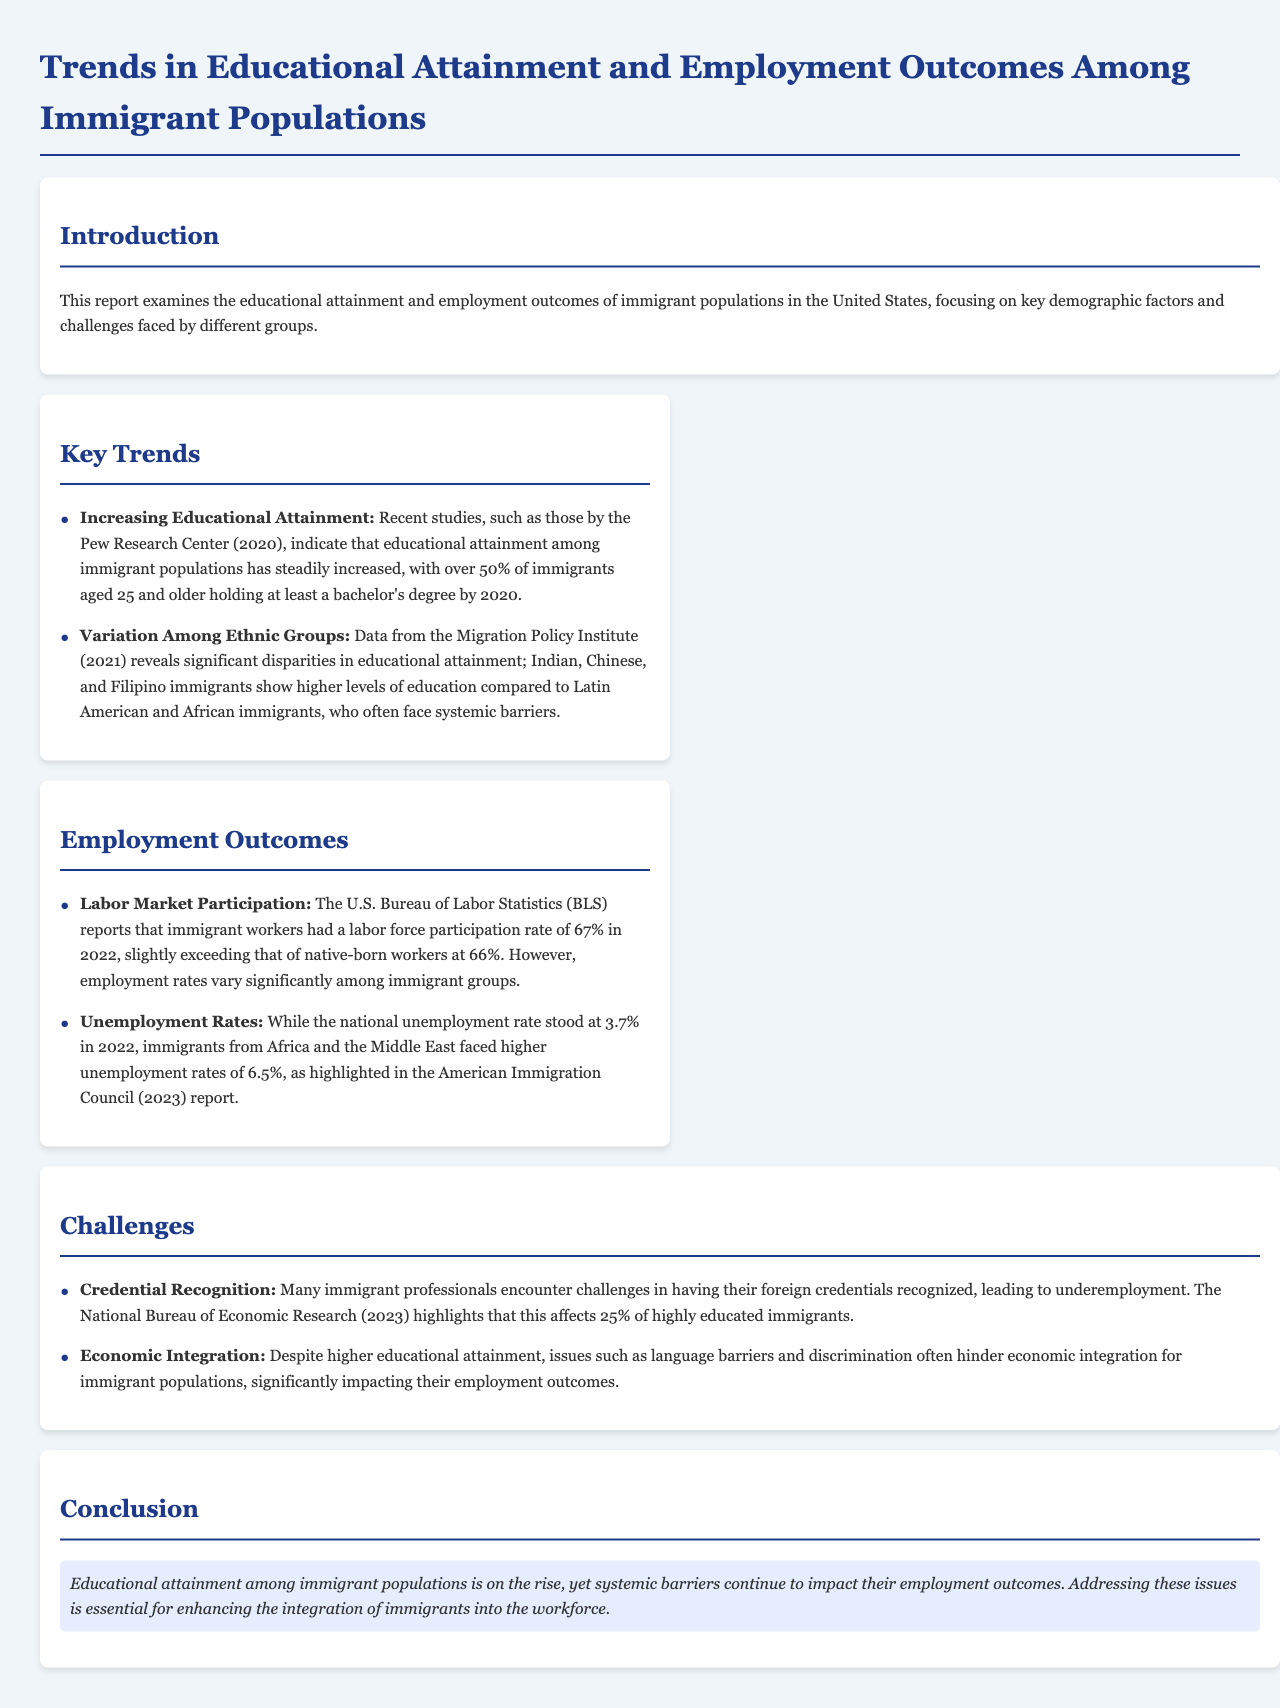what is the labor force participation rate of immigrant workers in 2022? The labor force participation rate for immigrant workers reported in 2022 is 67%.
Answer: 67% what percentage of immigrants aged 25 and older held at least a bachelor's degree by 2020? The document states that over 50% of immigrants aged 25 and older held at least a bachelor's degree by 2020.
Answer: over 50% which ethnic groups show higher levels of education among immigrants? The document specifies that Indian, Chinese, and Filipino immigrants show higher levels of education compared to others.
Answer: Indian, Chinese, and Filipino what is the unemployment rate for immigrants from Africa and the Middle East in 2022? It is highlighted in the document that immigrants from Africa and the Middle East faced unemployment rates of 6.5% in 2022.
Answer: 6.5% what challenge do many immigrant professionals face regarding their credentials? The document mentions that many immigrant professionals face challenges in having their foreign credentials recognized.
Answer: Credential recognition what is the national unemployment rate in 2022? The national unemployment rate reported in 2022 is 3.7%.
Answer: 3.7% which organization highlights that 25% of highly educated immigrants face credential recognition issues? The National Bureau of Economic Research is the organization that highlights this issue.
Answer: National Bureau of Economic Research what is a significant barrier to economic integration for immigrant populations? Issues such as language barriers and discrimination are cited as significant barriers to economic integration.
Answer: Language barriers and discrimination 